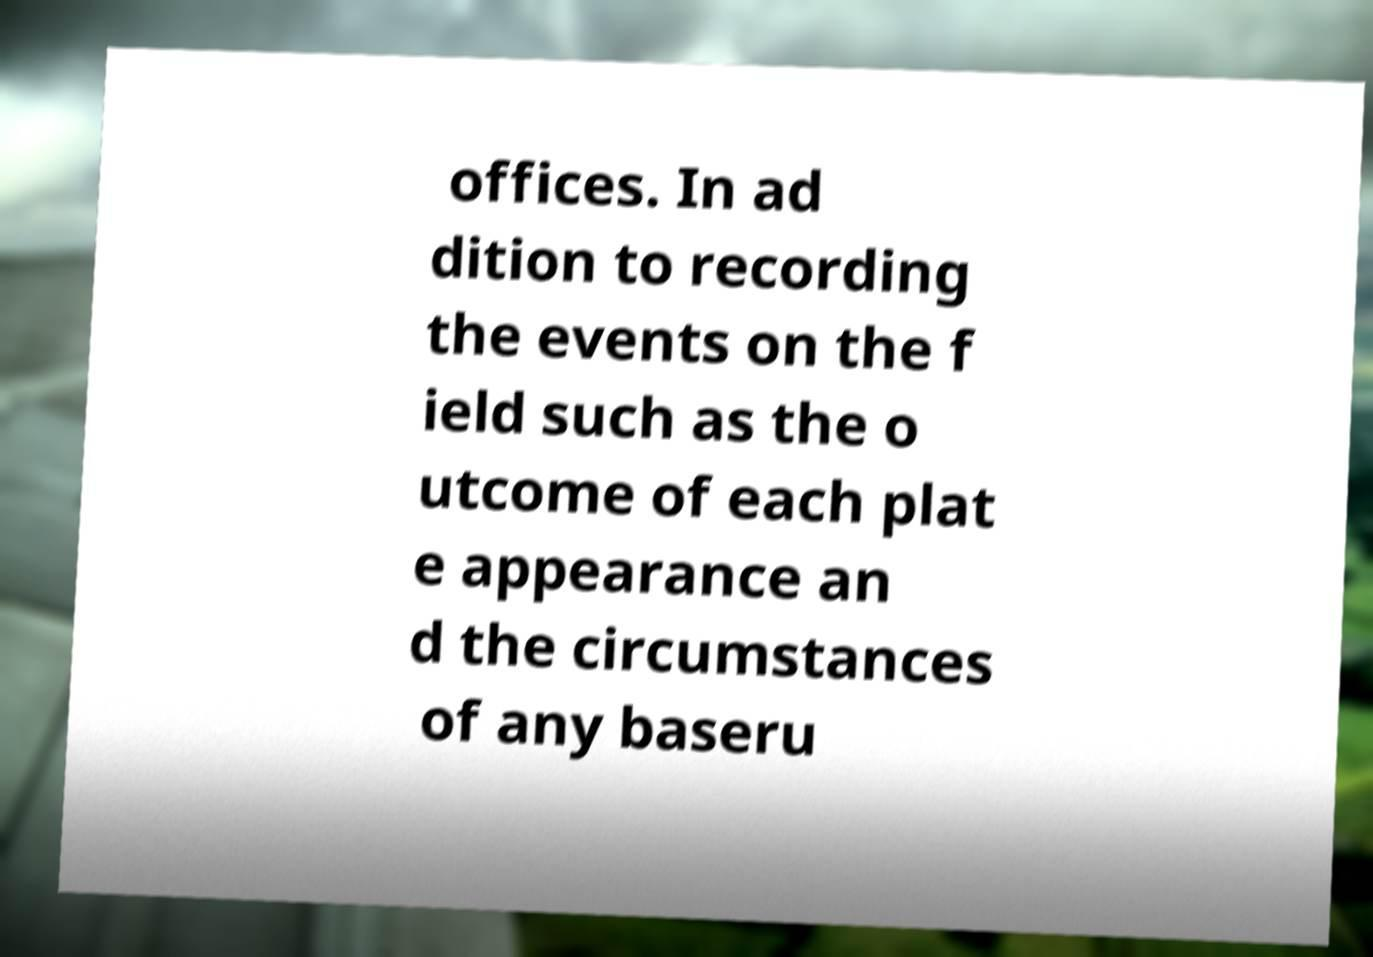What messages or text are displayed in this image? I need them in a readable, typed format. offices. In ad dition to recording the events on the f ield such as the o utcome of each plat e appearance an d the circumstances of any baseru 